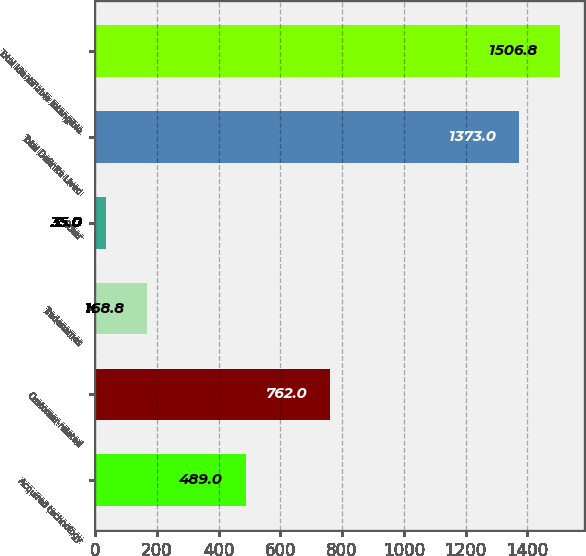Convert chart. <chart><loc_0><loc_0><loc_500><loc_500><bar_chart><fcel>Acquired technology<fcel>Customer-related<fcel>Tradenames<fcel>Other<fcel>Total Definite Lived<fcel>Total Identifiable Intangible<nl><fcel>489<fcel>762<fcel>168.8<fcel>35<fcel>1373<fcel>1506.8<nl></chart> 